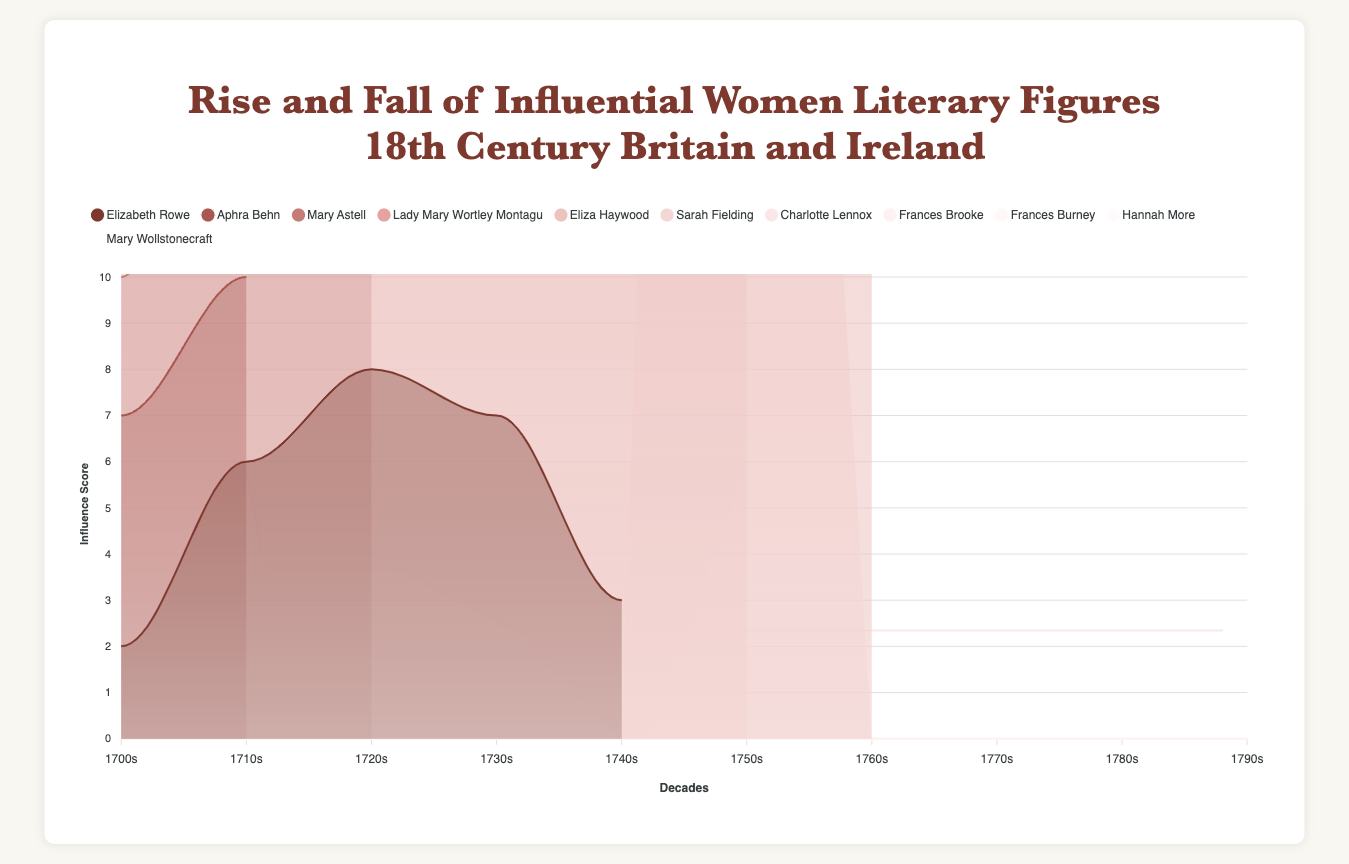What is the overall title of the chart? The title is prominently displayed at the top of the chart in large font. It reads, "Rise and Fall of Influential Women Literary Figures, 18th Century Britain and Ireland".
Answer: Rise and Fall of Influential Women Literary Figures, 18th Century Britain and Ireland How are the influence scores over decades visually represented in the chart? The influence scores are represented using stacked area charts. Each author's influence over time is shown as an area shaded in different colors, stacked to show cumulative influence.
Answer: Stacked area charts Which decade shows the highest influence score for Elizabeth Rowe? To find this, look at the area chart and identify the tallest segment for Elizabeth Rowe's color. It peaks in the 1720s.
Answer: 1720s Whose influence began in the 1720s and increased in the subsequent decades? By identifying the color segments that start in the 1720s and looking at their growth, we see that Eliza Haywood's influence starts in the 1720s and rises.
Answer: Eliza Haywood Compare Lady Mary Wortley Montagu's influence in the 1750s and 1760s. Look at the height of Lady Mary Wortley Montagu's segment in the 1750s and 1760s. Her influence is higher in the 1750s than in the 1760s.
Answer: Higher in the 1750s Who had the highest influence score in the 1780s? To determine this, observe which author’s area segment is the tallest in the 1780s. Frances Burney has the highest influence score in this decade.
Answer: Frances Burney When did Sarah Fielding start appearing in the influence scores? Identify the first decade with a segment for Sarah Fielding. It starts in the 1740s.
Answer: 1740s What is the general trend of Frances Burney's influence from the 1770s to the 1790s? Track Frances Burney's area segment from the 1770s to the 1790s. It shows an increasing trend, peaking in the 1780s and maintaining high in the 1790s.
Answer: Increasing Which decade shows the most diverse set of influential women writers (i.e., the most individual segments)? Count the number of authors represented in each decade. The 1710s, 1740s, and 1790s have the most diverse set, each with four authors.
Answer: 1710s, 1740s, 1790s Calculate the sum of influence scores for all authors in the 1730s. Add up the influence scores for Elizabeth Rowe, Lady Mary Wortley Montagu, and Eliza Haywood in the 1730s. The sum is 7 + 6 + 6 = 19.
Answer: 19 